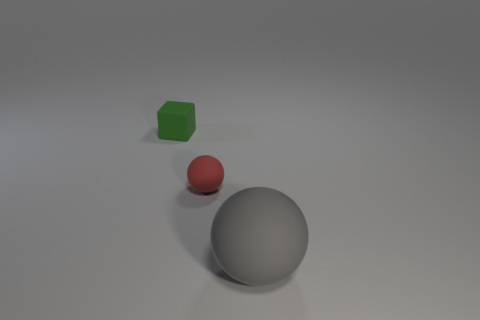Do the red ball and the green object have the same size?
Your answer should be very brief. Yes. What is the size of the matte object in front of the small matte object in front of the tiny green rubber thing?
Offer a terse response. Large. Do the matte cube and the rubber ball behind the large gray rubber object have the same color?
Offer a terse response. No. Are there any matte cubes that have the same size as the red matte sphere?
Offer a terse response. Yes. What is the size of the rubber sphere behind the gray thing?
Keep it short and to the point. Small. There is a small matte thing that is in front of the green thing; is there a green thing behind it?
Offer a very short reply. Yes. What number of other objects are there of the same shape as the green matte thing?
Keep it short and to the point. 0. Do the large gray matte object and the tiny red object have the same shape?
Offer a terse response. Yes. There is a rubber thing that is both in front of the tiny block and left of the gray matte sphere; what color is it?
Offer a very short reply. Red. What number of tiny things are spheres or green rubber cubes?
Make the answer very short. 2. 